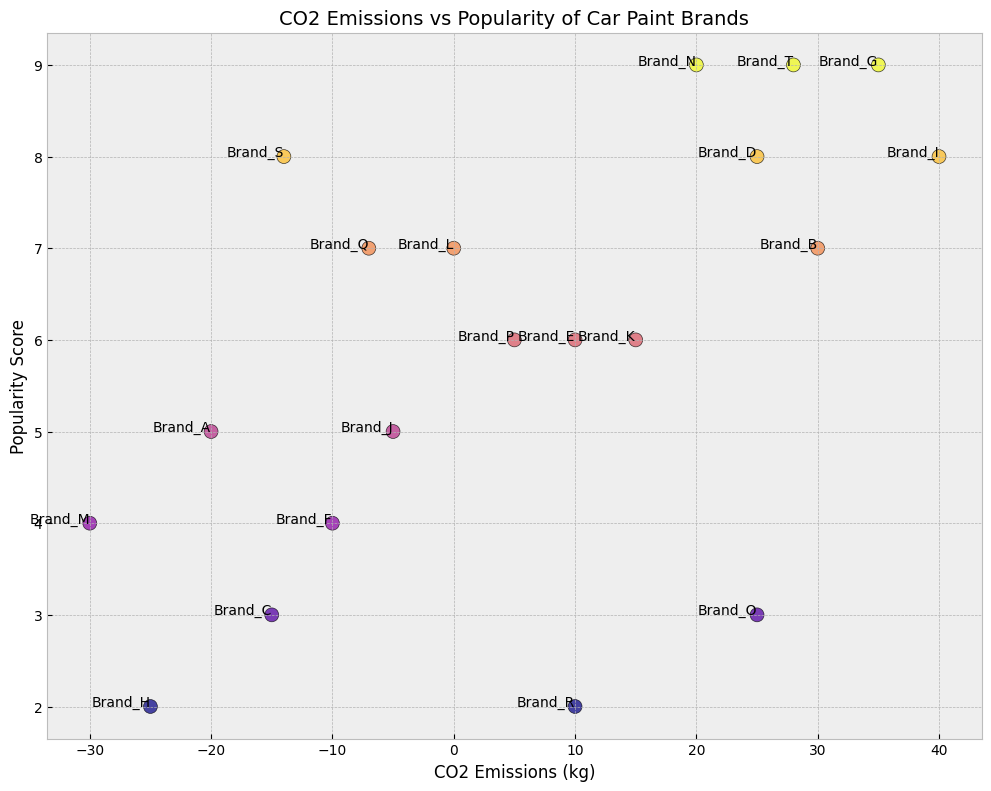Which car paint brand has the highest CO2 emissions? To find the car paint brand with the highest CO2 emissions, look for the data point with the largest CO2 value on the x-axis. The brand corresponding to the highest value on the x-axis is Brand I with 40 kg.
Answer: Brand I Among the car paint brands, which two have the lowest popularity? To determine the brands with the lowest popularity, look for data points with the lowest values on the y-axis. The two brands with the lowest popularity scores are Brand H and Brand R, both having a score of 2.
Answer: Brand H and Brand R What is the range of CO2 emissions for the car paint brands? The range is calculated by subtracting the lowest CO2 emission value from the highest. The minimum CO2 emission is -30 kg (Brand M), and the maximum is 40 kg (Brand I). Thus, the range is 40 - (-30) = 70 kg.
Answer: 70 kg Which brand has the highest popularity with negative CO2 emissions? Look for the data points with negative CO2 emissions and then identify the one with the highest popularity value on the y-axis. Brand S has a popularity score of 8 and a CO2 emission of -14 kg.
Answer: Brand S What is the average popularity of brands with CO2 emissions of 25 kg? Identify the brands with CO2 emissions of 25 kg (Brand D and Brand O) and then calculate their average popularity. Brand D has a popularity of 8 and Brand O has a popularity of 3. The average = (8 + 3) / 2 = 5.5.
Answer: 5.5 Which brands lie in the negative CO2 emissions range but have a popularity score of 5 or more? Scan the plot for brands with CO2 emissions less than 0 and popularity scores greater than or equal to 5. These brands are Brand A (5), Brand J (5), and Brand Q (7).
Answer: Brand A, Brand J, and Brand Q What’s the combined popularity score for all brands with CO2 emissions greater than or equal to 30 kg? Identify the brands (Brand B, Brand G, Brand I, Brand T) with CO2 emissions greater than or equal to 30 kg and sum their popularity scores. The combined score = 7 + 9 + 8 + 9 = 33.
Answer: 33 Compare the popularity of Brand E and Brand K. Look at the popularity scores on the y-axis for Brand E and Brand K. Both have a popularity score of 6.
Answer: They have equal popularity Which brand has the most balanced position between CO2 emissions and popularity scores? Look for a brand that lies close to the center of the scatter plot around both the x-axis and y-axis midpoints. The brand closest to the center, with CO2 emissions close to 0 and moderate popularity, is Brand L, which has 0 kg CO2 emissions and a popularity score of 7.
Answer: Brand L Which brands have CO2 emissions less than -10 kg but are in the top half of the popularity scores (higher than 4.5)? Identify the brands with CO2 emissions less than -10 kg and popularity scores greater than 4.5. These brands are Brand A (5), Brand S (8), and Brand Q (7).
Answer: Brand A, Brand S, and Brand Q 